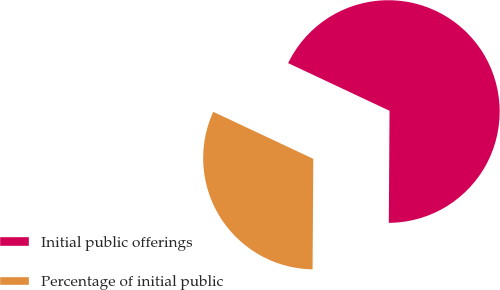<chart> <loc_0><loc_0><loc_500><loc_500><pie_chart><fcel>Initial public offerings<fcel>Percentage of initial public<nl><fcel>68.11%<fcel>31.89%<nl></chart> 